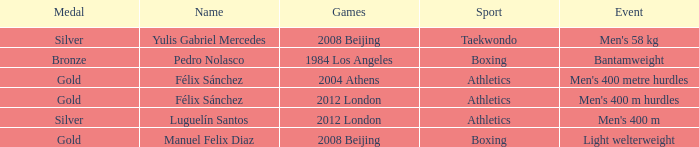Which Name had a Games of 2008 beijing, and a Medal of gold? Manuel Felix Diaz. 